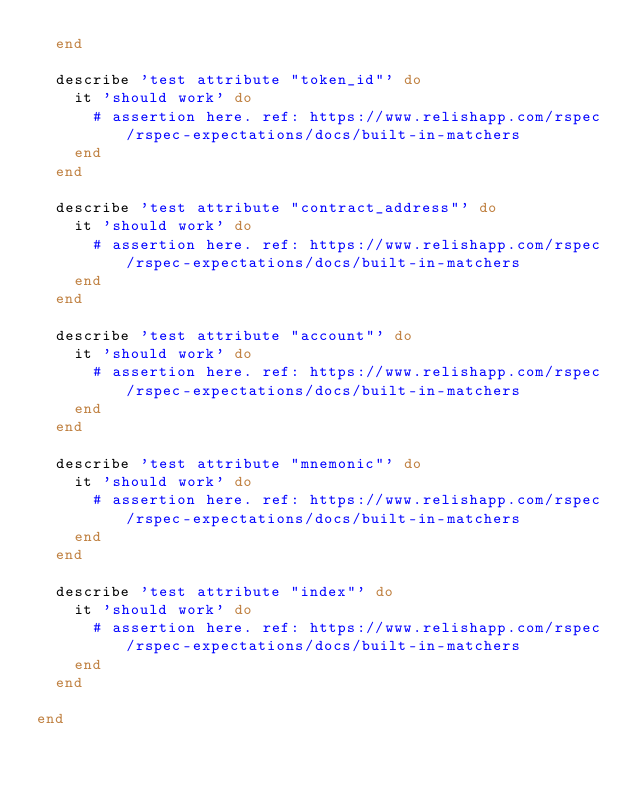<code> <loc_0><loc_0><loc_500><loc_500><_Ruby_>  end

  describe 'test attribute "token_id"' do
    it 'should work' do
      # assertion here. ref: https://www.relishapp.com/rspec/rspec-expectations/docs/built-in-matchers
    end
  end

  describe 'test attribute "contract_address"' do
    it 'should work' do
      # assertion here. ref: https://www.relishapp.com/rspec/rspec-expectations/docs/built-in-matchers
    end
  end

  describe 'test attribute "account"' do
    it 'should work' do
      # assertion here. ref: https://www.relishapp.com/rspec/rspec-expectations/docs/built-in-matchers
    end
  end

  describe 'test attribute "mnemonic"' do
    it 'should work' do
      # assertion here. ref: https://www.relishapp.com/rspec/rspec-expectations/docs/built-in-matchers
    end
  end

  describe 'test attribute "index"' do
    it 'should work' do
      # assertion here. ref: https://www.relishapp.com/rspec/rspec-expectations/docs/built-in-matchers
    end
  end

end
</code> 